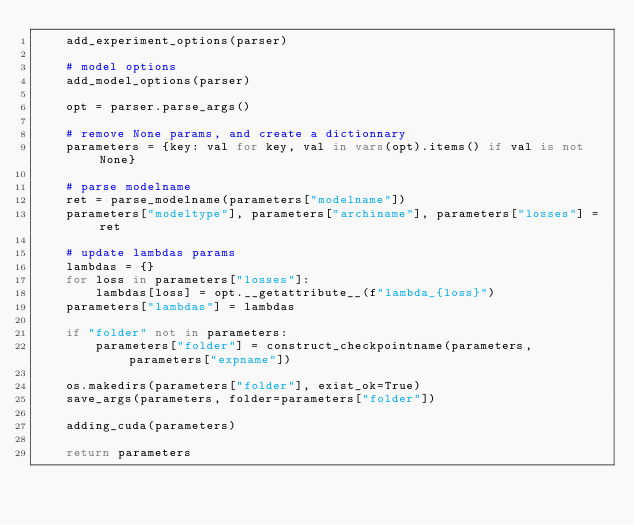<code> <loc_0><loc_0><loc_500><loc_500><_Python_>    add_experiment_options(parser)

    # model options
    add_model_options(parser)

    opt = parser.parse_args()
    
    # remove None params, and create a dictionnary
    parameters = {key: val for key, val in vars(opt).items() if val is not None}

    # parse modelname
    ret = parse_modelname(parameters["modelname"])
    parameters["modeltype"], parameters["archiname"], parameters["losses"] = ret
    
    # update lambdas params
    lambdas = {}
    for loss in parameters["losses"]:
        lambdas[loss] = opt.__getattribute__(f"lambda_{loss}")
    parameters["lambdas"] = lambdas
    
    if "folder" not in parameters:
        parameters["folder"] = construct_checkpointname(parameters, parameters["expname"])

    os.makedirs(parameters["folder"], exist_ok=True)
    save_args(parameters, folder=parameters["folder"])

    adding_cuda(parameters)
    
    return parameters
</code> 